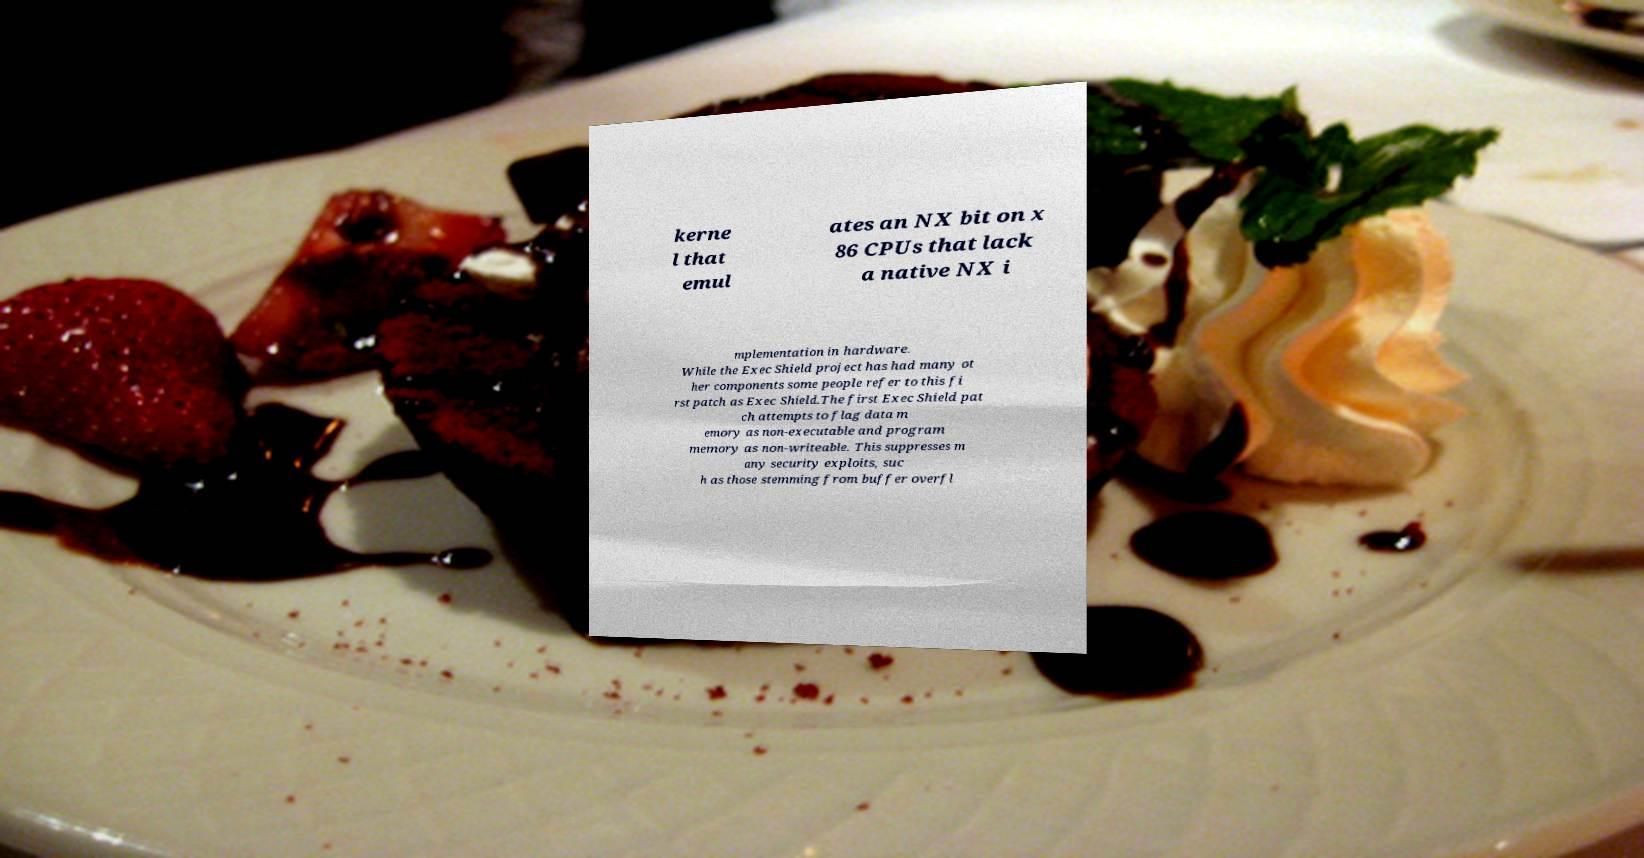Please read and relay the text visible in this image. What does it say? kerne l that emul ates an NX bit on x 86 CPUs that lack a native NX i mplementation in hardware. While the Exec Shield project has had many ot her components some people refer to this fi rst patch as Exec Shield.The first Exec Shield pat ch attempts to flag data m emory as non-executable and program memory as non-writeable. This suppresses m any security exploits, suc h as those stemming from buffer overfl 